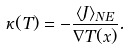<formula> <loc_0><loc_0><loc_500><loc_500>\kappa ( T ) = - \frac { \langle J \rangle _ { N E } } { \nabla T ( x ) } .</formula> 